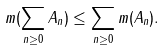Convert formula to latex. <formula><loc_0><loc_0><loc_500><loc_500>m ( \sum _ { n \geq 0 } A _ { n } ) \leq \sum _ { n \geq 0 } m ( A _ { n } ) .</formula> 